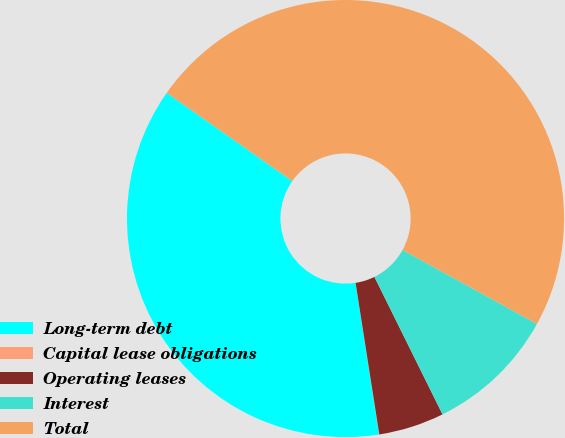<chart> <loc_0><loc_0><loc_500><loc_500><pie_chart><fcel>Long-term debt<fcel>Capital lease obligations<fcel>Operating leases<fcel>Interest<fcel>Total<nl><fcel>37.2%<fcel>0.02%<fcel>4.85%<fcel>9.67%<fcel>48.26%<nl></chart> 